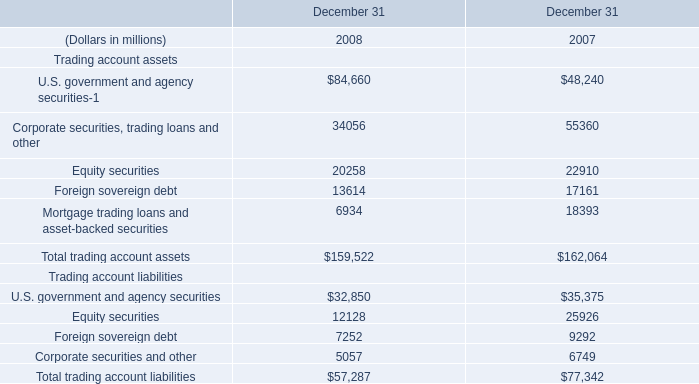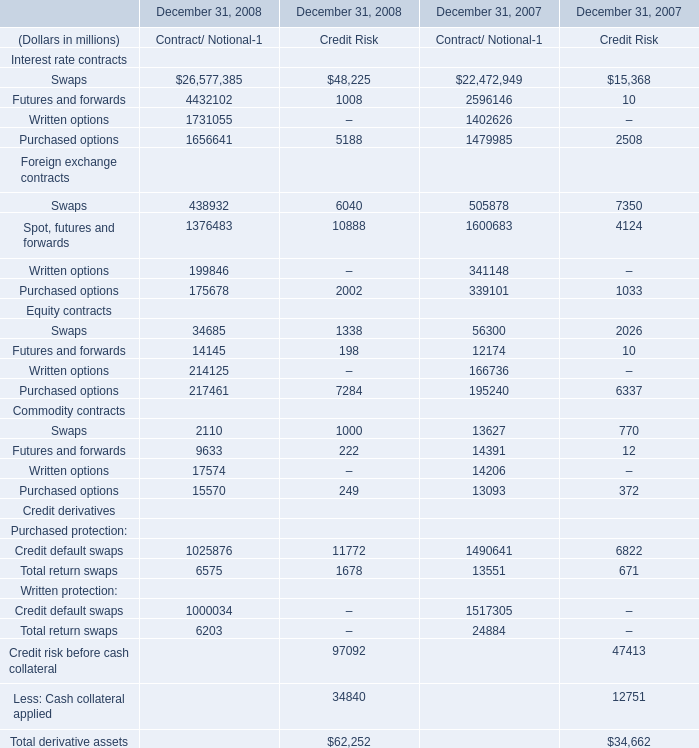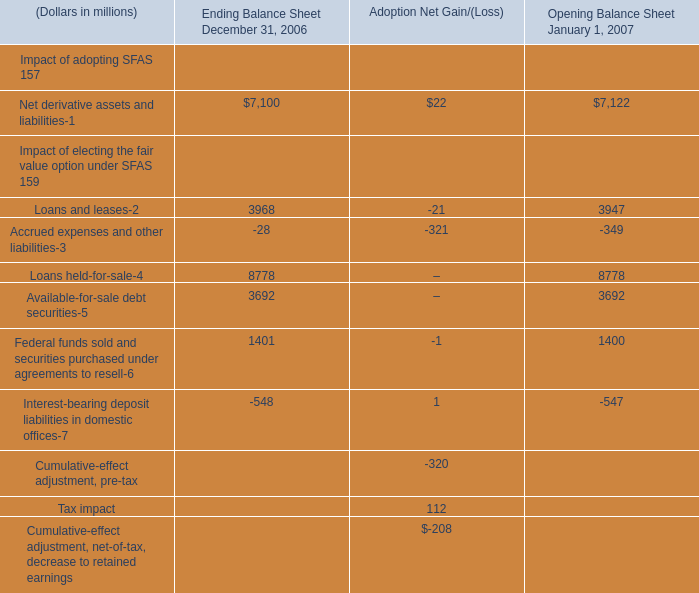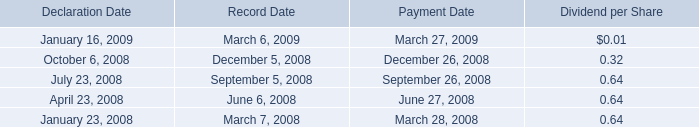what's the total amount of Written options Commodity contracts of December 31, 2007 Contract/ Notional, Foreign sovereign debt of December 31 2007, and Net derivative assets and liabilities of Ending Balance Sheet December 31, 2006 ? 
Computations: ((14206.0 + 17161.0) + 7100.0)
Answer: 38467.0. 